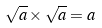Convert formula to latex. <formula><loc_0><loc_0><loc_500><loc_500>\sqrt { a } \times \sqrt { a } = a</formula> 